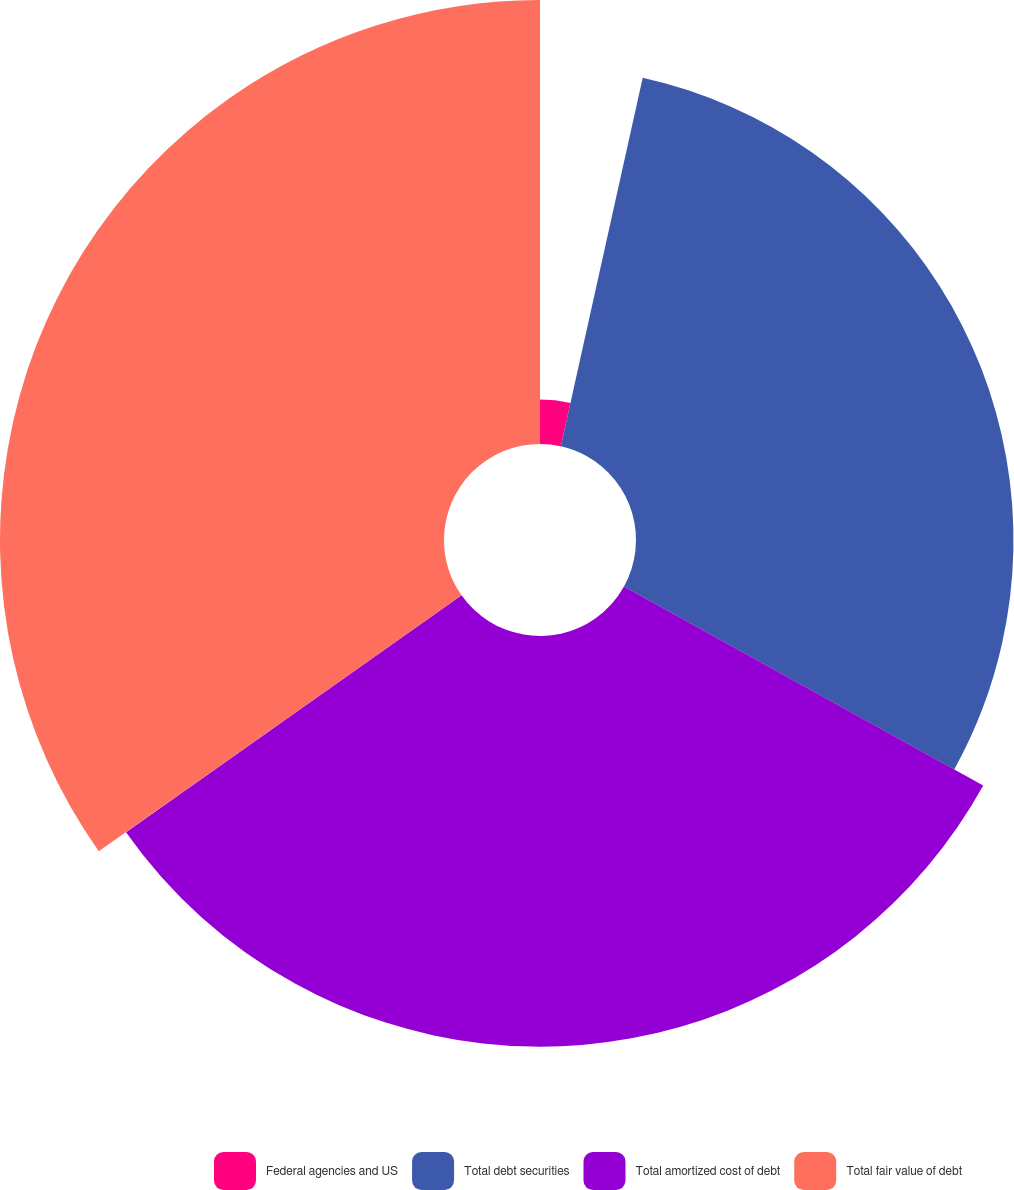Convert chart to OTSL. <chart><loc_0><loc_0><loc_500><loc_500><pie_chart><fcel>Federal agencies and US<fcel>Total debt securities<fcel>Total amortized cost of debt<fcel>Total fair value of debt<nl><fcel>3.48%<fcel>29.57%<fcel>32.17%<fcel>34.78%<nl></chart> 